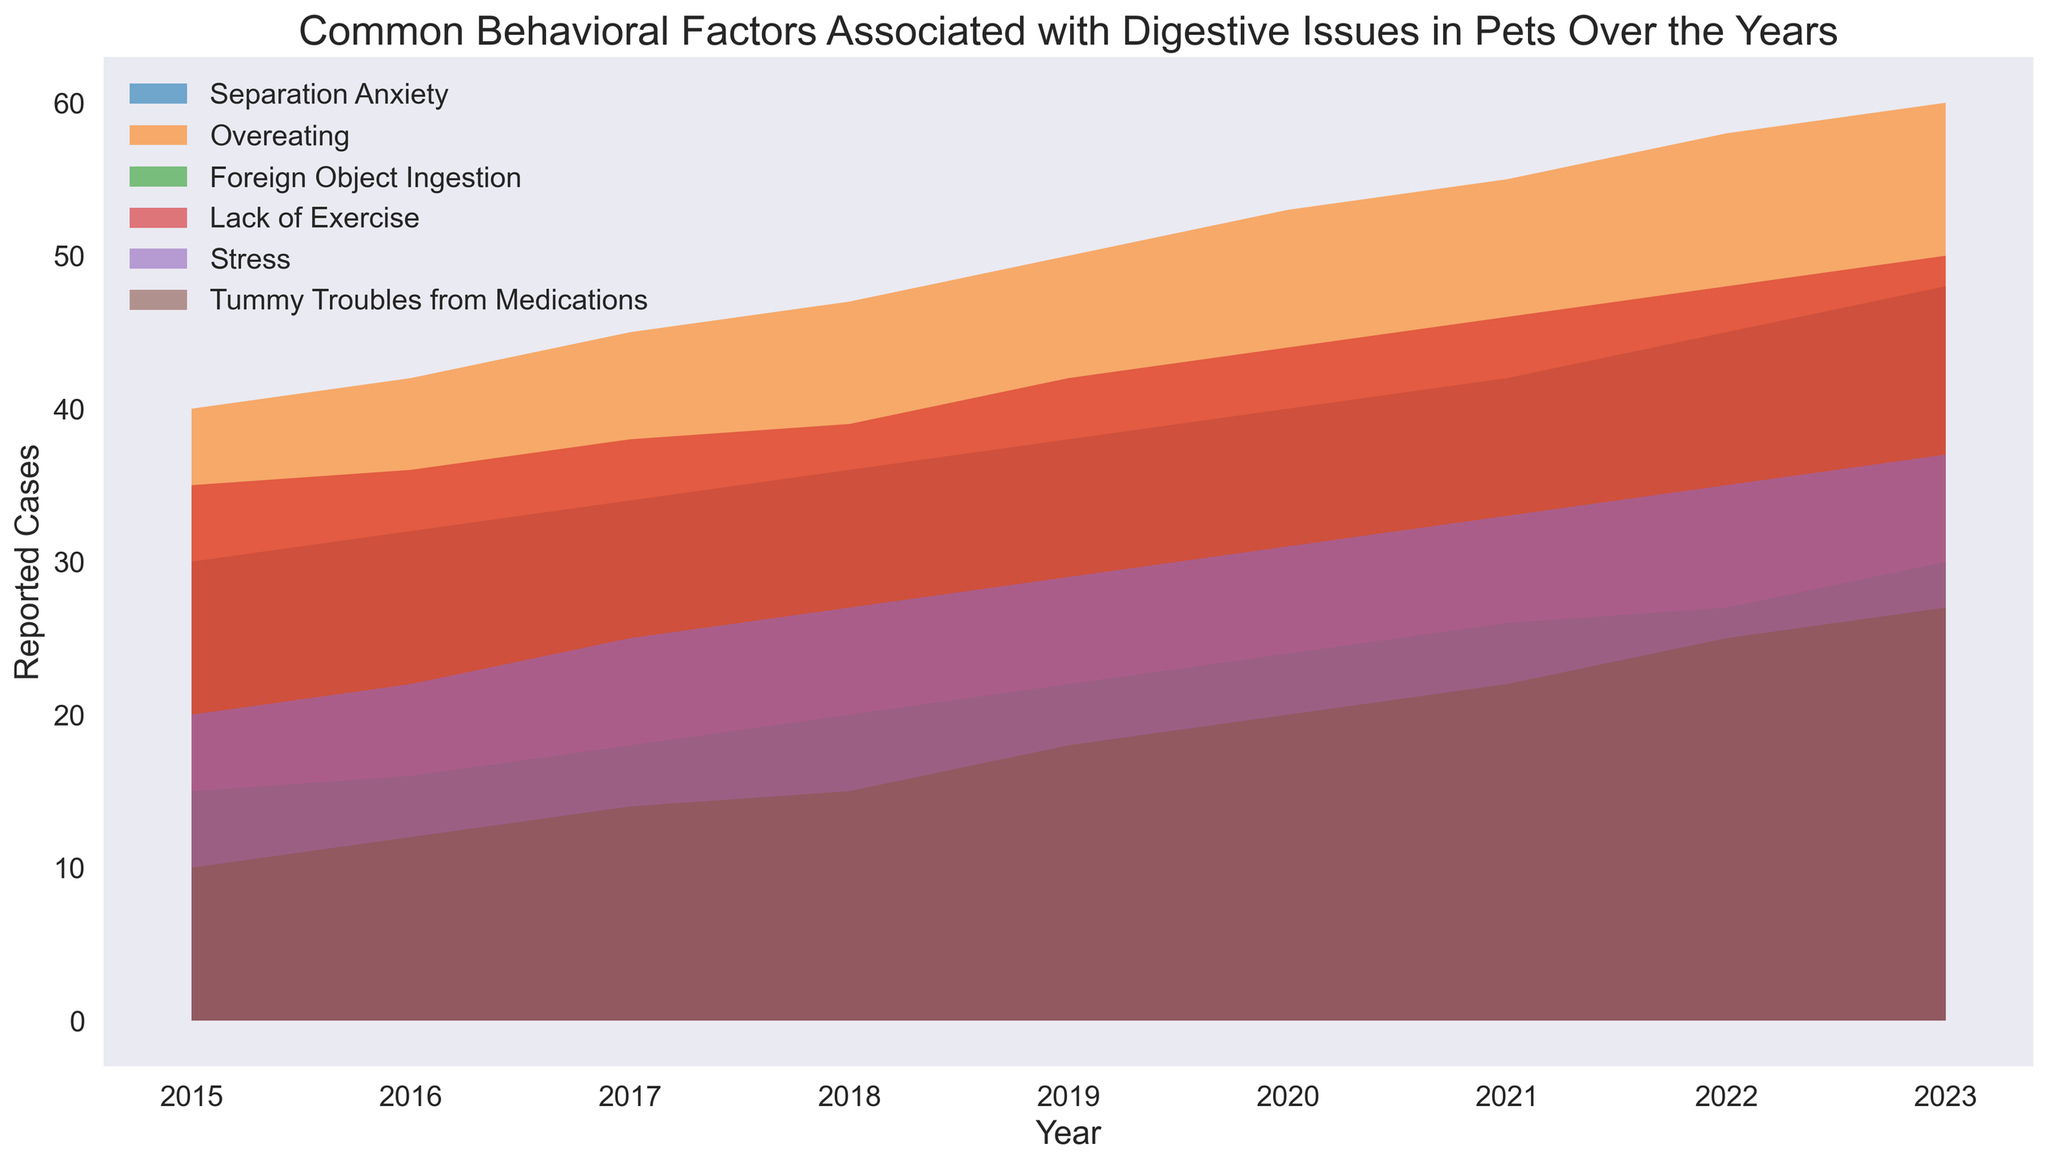What behavioral factor shows the highest increase in reported cases from 2015 to 2023? To find the behavioral factor with the highest increase, subtract the 2015 value from the 2023 value for each factor. Compare the differences: Separation Anxiety (48-30=18), Overeating (60-40=20), Foreign Object Ingestion (30-15=15), Lack of Exercise (50-35=15), Stress (37-20=17), Tummy Troubles from Medications (27-10=17). Overeating has the highest increase.
Answer: Overeating Which year shows the highest number of reported cases of Lack of Exercise? Look at the figure and identify the tallest area representing Lack of Exercise for each year. The highest point is in 2023 with 50 reported cases.
Answer: 2023 Which two factors had the exact same number of reported cases in any given year? Examine each year in the figure to find matching heights of different areas. In 2017, Foreign Object Ingestion and Tummy Troubles from Medications both have 18 reported cases.
Answer: Foreign Object Ingestion and Tummy Troubles from Medications in 2017 What is the total number of reported cases for all factors combined in 2018? Sum the reported cases for all factors: Separation Anxiety (36), Overeating (47), Foreign Object Ingestion (20), Lack of Exercise (39), Stress (27), and Tummy Troubles from Medications (15). Total = 36+47+20+39+27+15 = 184.
Answer: 184 Which behavioral factor has the smallest average reported cases over the years? Calculate the average for each factor: Separation Anxiety (30+32+34+36+38+40+42+45+48)/9, Overeating (40+42+45+47+50+53+55+58+60)/9, Foreign Object Ingestion (15+16+18+20+22+24+26+27+30)/9, Lack of Exercise (35+36+38+39+42+44+46+48+50)/9, Stress (20+22+25+27+29+31+33+35+37)/9, Tummy Troubles from Medications (10+12+14+15+18+20+22+25+27)/9. Tummy Troubles from Medications has the smallest average.
Answer: Tummy Troubles from Medications Between which two consecutive years did Stress show the largest increase in reported cases? Subtract Stress cases between the consecutive years: (22-20)=2 (2015-2016), (25-22)=3 (2016-2017), (27-25)=2 (2017-2018), (29-27)=2 (2018-2019), (31-29)=2 (2019-2020), (33-31)=2 (2020-2021), (35-33)=2 (2021-2022), (37-35)=2 (2022-2023). The largest increase is between 2016 and 2017 with 3 cases.
Answer: 2016 to 2017 What is the visual trend of Foreign Object Ingestion from 2015 to 2023? Observe the area representing Foreign Object Ingestion in the figure; the height gradually increases from 2015 to 2023, indicating a steady rise in reported cases over the years.
Answer: Steady increase 